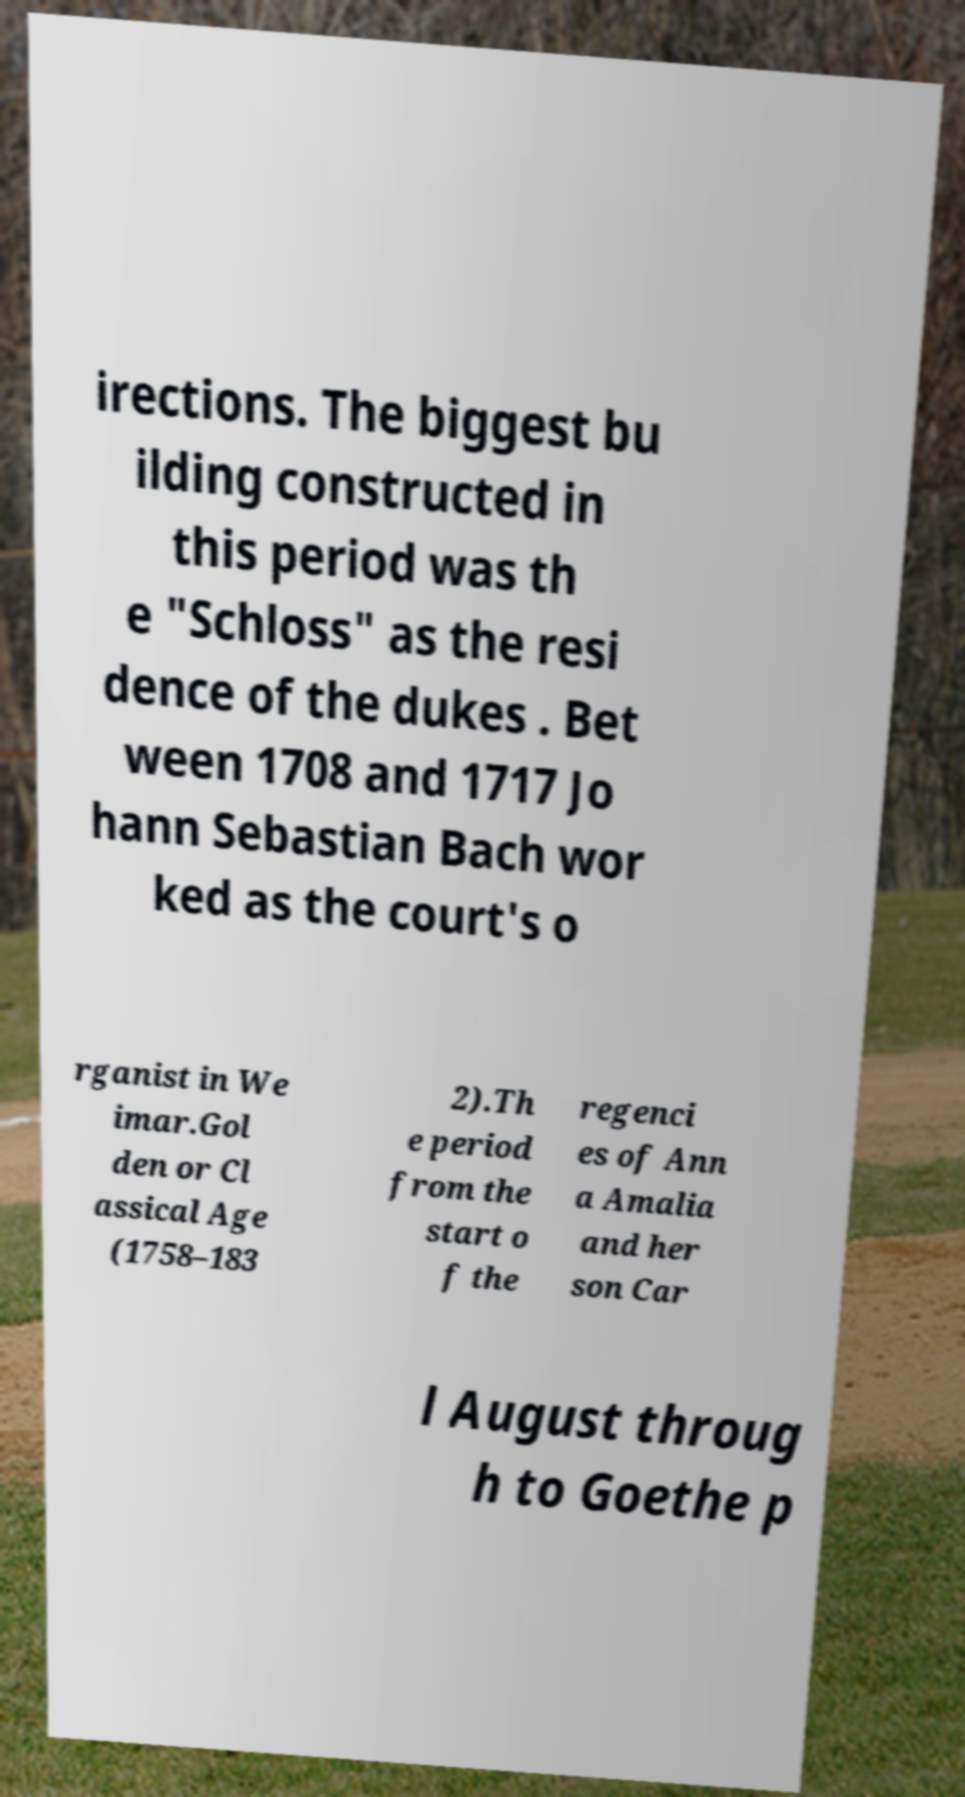I need the written content from this picture converted into text. Can you do that? irections. The biggest bu ilding constructed in this period was th e "Schloss" as the resi dence of the dukes . Bet ween 1708 and 1717 Jo hann Sebastian Bach wor ked as the court's o rganist in We imar.Gol den or Cl assical Age (1758–183 2).Th e period from the start o f the regenci es of Ann a Amalia and her son Car l August throug h to Goethe p 